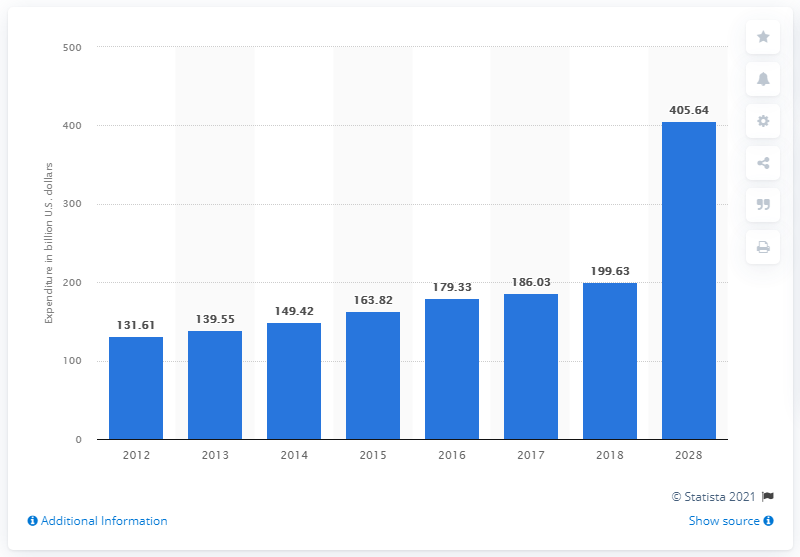Specify some key components in this picture. According to a forecast, India's domestic tourism expenditure is expected to nearly double its expenditure in 2018 by the year 2028. In 2018, the domestic expenditure on tourism in India was 199.63... In 2017, India's tourism expenditure was 186.03 billion rupees. 